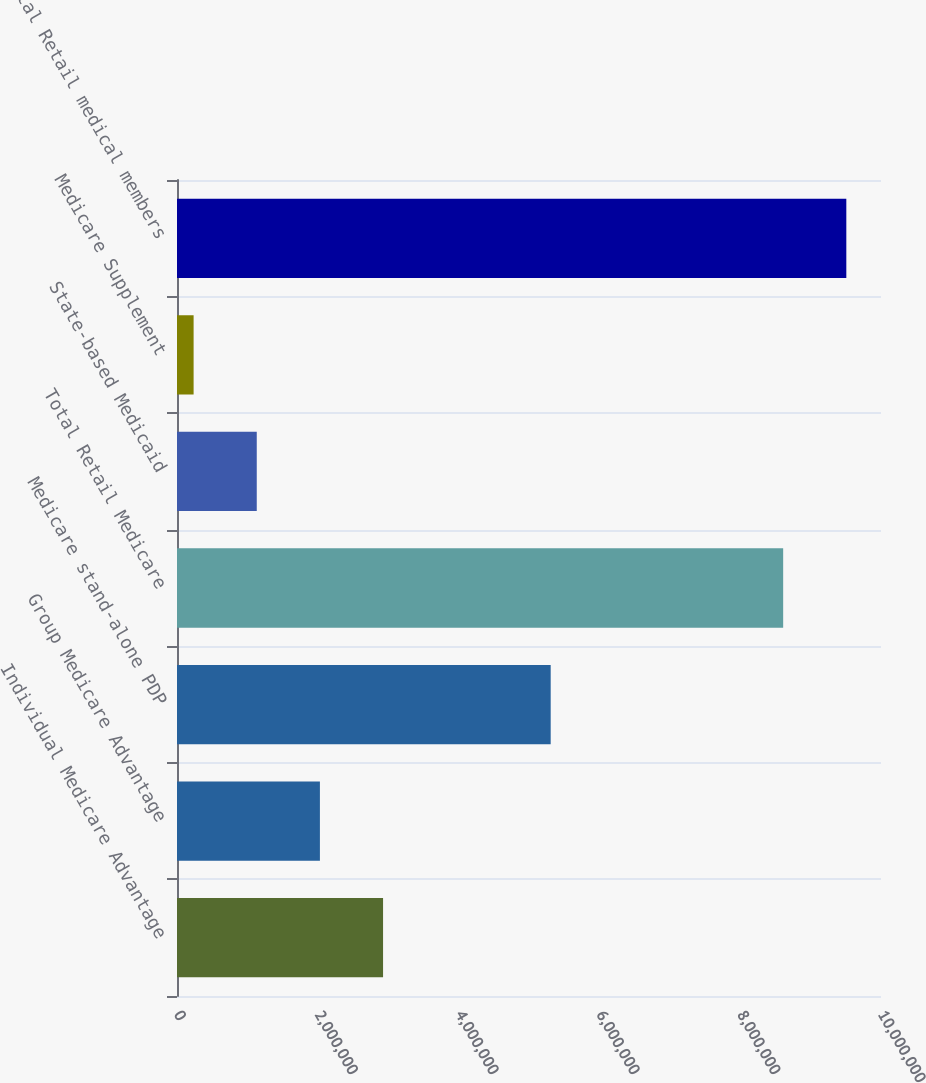<chart> <loc_0><loc_0><loc_500><loc_500><bar_chart><fcel>Individual Medicare Advantage<fcel>Group Medicare Advantage<fcel>Medicare stand-alone PDP<fcel>Total Retail Medicare<fcel>State-based Medicaid<fcel>Medicare Supplement<fcel>Total Retail medical members<nl><fcel>2.92702e+06<fcel>2.02998e+06<fcel>5.3081e+06<fcel>8.6103e+06<fcel>1.13294e+06<fcel>235900<fcel>9.50734e+06<nl></chart> 